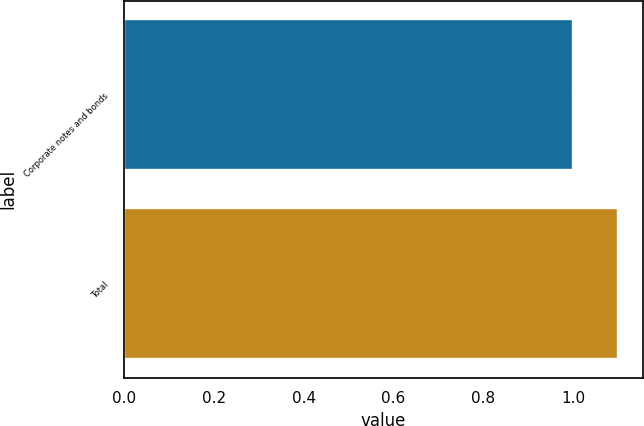Convert chart to OTSL. <chart><loc_0><loc_0><loc_500><loc_500><bar_chart><fcel>Corporate notes and bonds<fcel>Total<nl><fcel>1<fcel>1.1<nl></chart> 